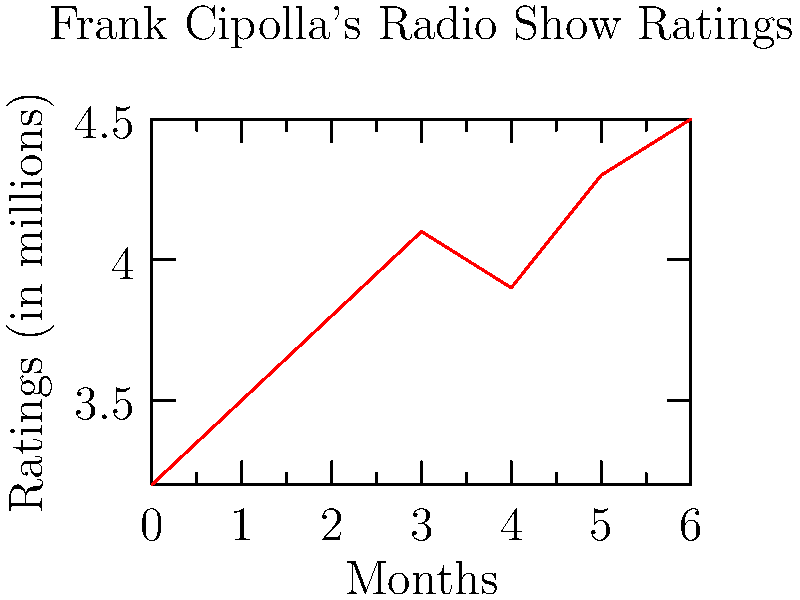Based on the line graph showing Frank Cipolla's radio show ratings over time, what is the overall trend in listener ratings, and what could be a potential factor contributing to this trend? To answer this question, we need to analyze the graph step-by-step:

1. Observe the general direction of the line:
   The line shows an overall upward trend from left to right.

2. Identify the starting and ending points:
   - Starting point (Month 0): approximately 3.2 million listeners
   - Ending point (Month 6): 4.5 million listeners

3. Calculate the total increase:
   $4.5 - 3.2 = 1.3$ million listeners

4. Analyze the rate of change:
   The line shows a fairly consistent upward trend, with a slight dip between months 4 and 5.

5. Interpret the trend:
   The overall trend is positive, indicating an increase in listener ratings over time.

6. Consider potential factors:
   As a journalism student familiar with Frank Cipolla's work, you might attribute this trend to:
   - Improved content quality
   - Increased marketing efforts
   - Growing popularity through word-of-mouth
   - Coverage of trending topics or exclusive interviews

7. Select a plausible factor:
   For this example, let's choose "coverage of trending topics or exclusive interviews" as a potential factor contributing to the ratings increase.
Answer: Increasing trend; possibly due to coverage of trending topics or exclusive interviews. 